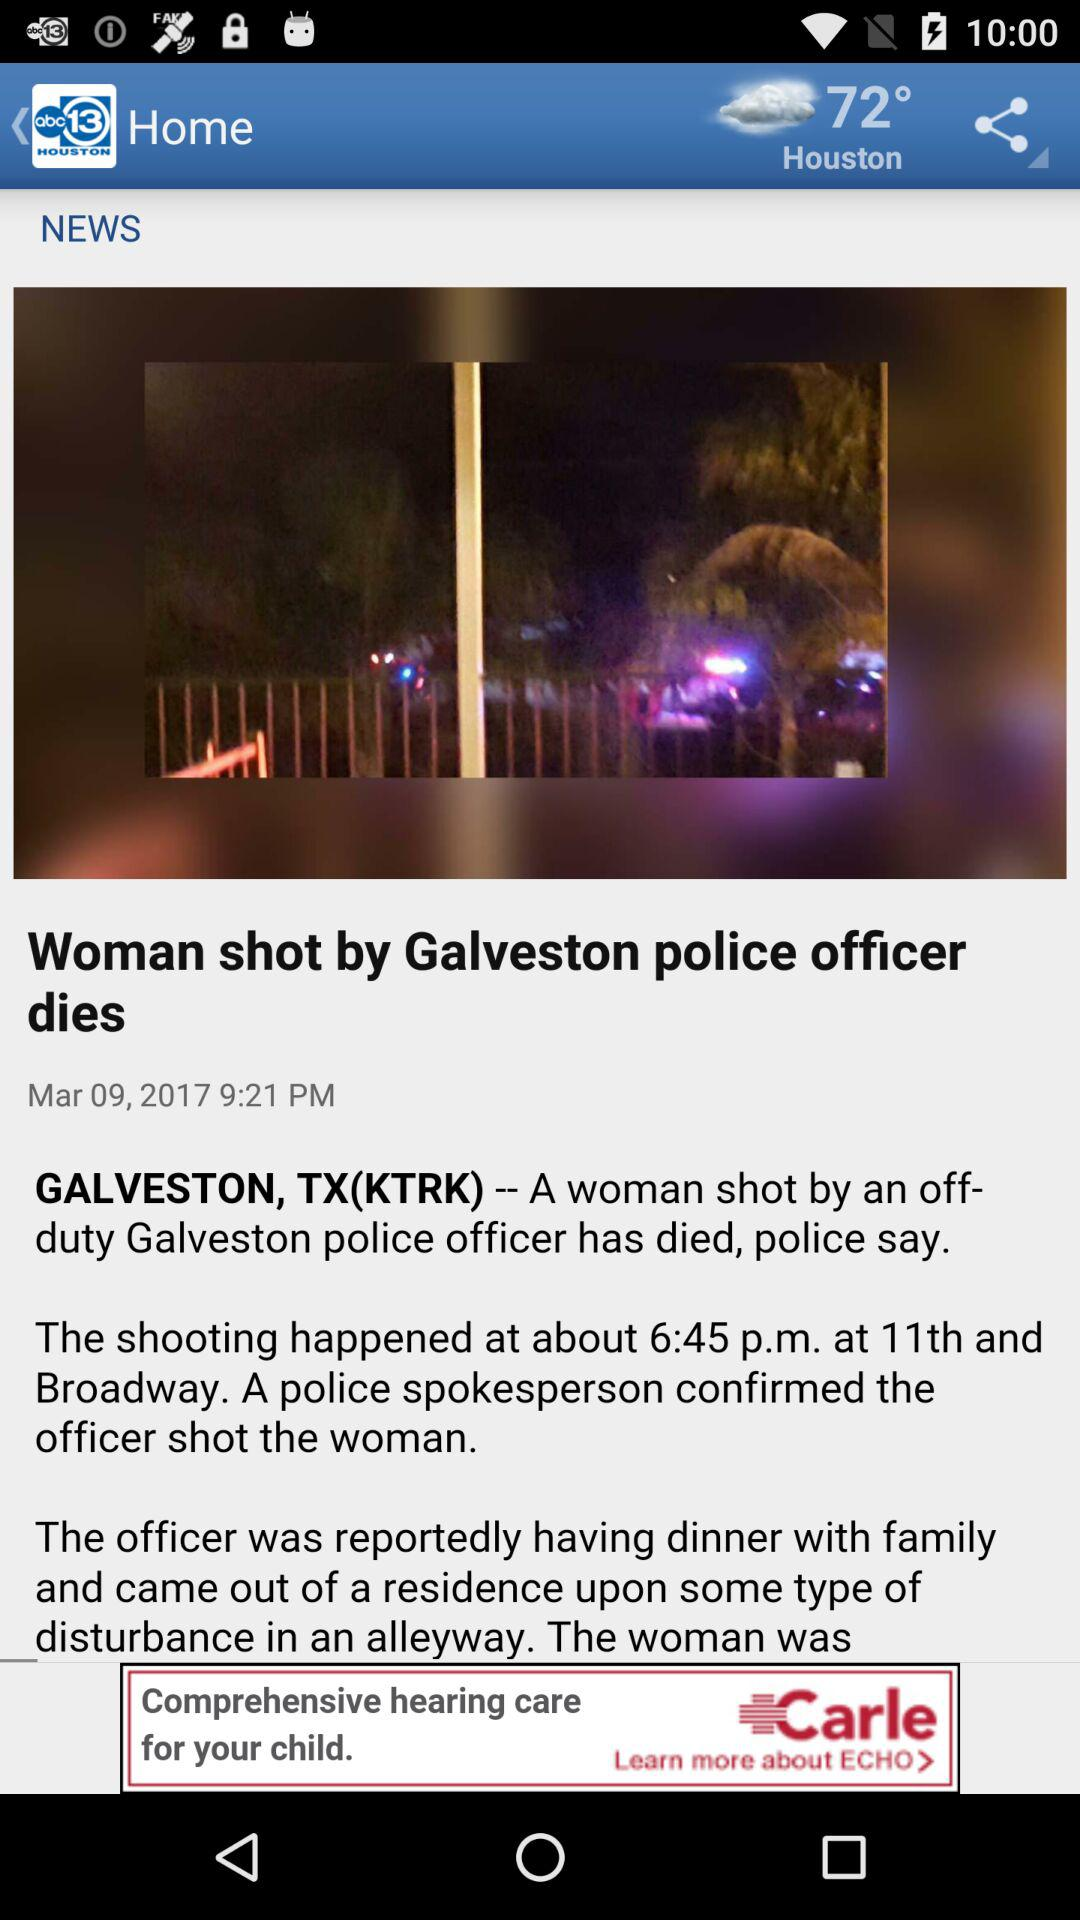What is the title of the news? The title of the news is "Woman shot by Galveston police officer dies". 